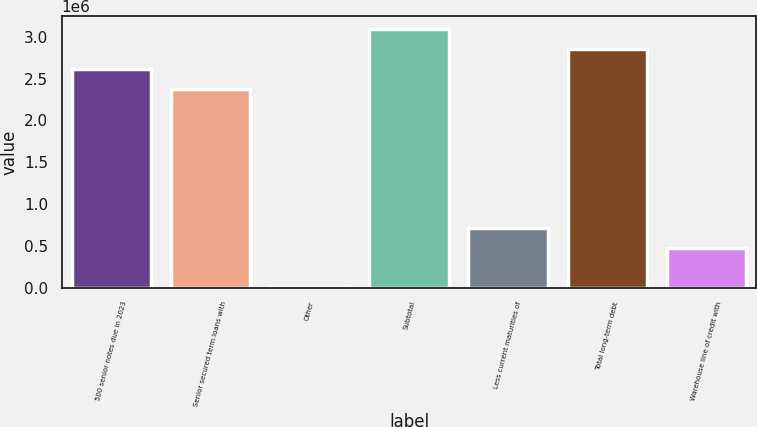<chart> <loc_0><loc_0><loc_500><loc_500><bar_chart><fcel>500 senior notes due in 2023<fcel>Senior secured term loans with<fcel>Other<fcel>Subtotal<fcel>Less current maturities of<fcel>Total long-term debt<fcel>Warehouse line of credit with<nl><fcel>2.61911e+06<fcel>2.38126e+06<fcel>2783<fcel>3.0948e+06<fcel>716326<fcel>2.85695e+06<fcel>478478<nl></chart> 